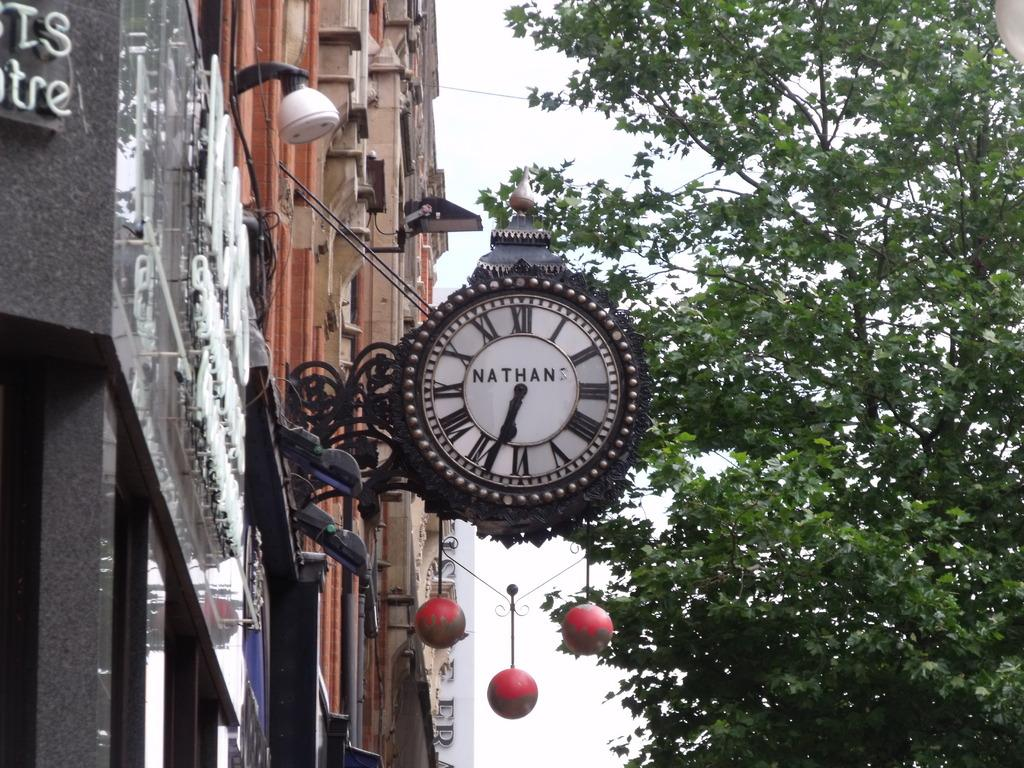<image>
Summarize the visual content of the image. A clock made by Nathan sticks out from a pawnbrokers and tells us it is 6:35 